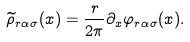Convert formula to latex. <formula><loc_0><loc_0><loc_500><loc_500>\widetilde { \rho } _ { r \alpha \sigma } ( x ) = \frac { r } { 2 \pi } \partial _ { x } \varphi _ { r \alpha \sigma } ( x ) .</formula> 